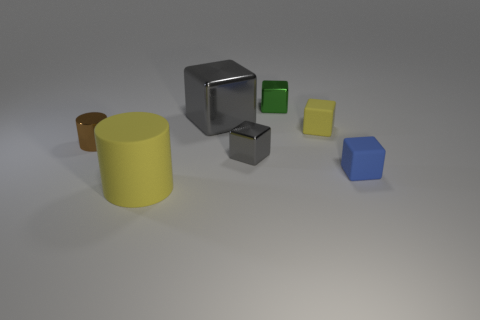Subtract all tiny blue matte blocks. How many blocks are left? 4 Subtract all gray blocks. How many blocks are left? 3 Subtract 2 cylinders. How many cylinders are left? 0 Add 3 big gray things. How many objects exist? 10 Subtract 1 brown cylinders. How many objects are left? 6 Subtract all cylinders. How many objects are left? 5 Subtract all red cylinders. Subtract all brown blocks. How many cylinders are left? 2 Subtract all purple cubes. How many brown cylinders are left? 1 Subtract all small gray metal objects. Subtract all large rubber cylinders. How many objects are left? 5 Add 1 blue rubber things. How many blue rubber things are left? 2 